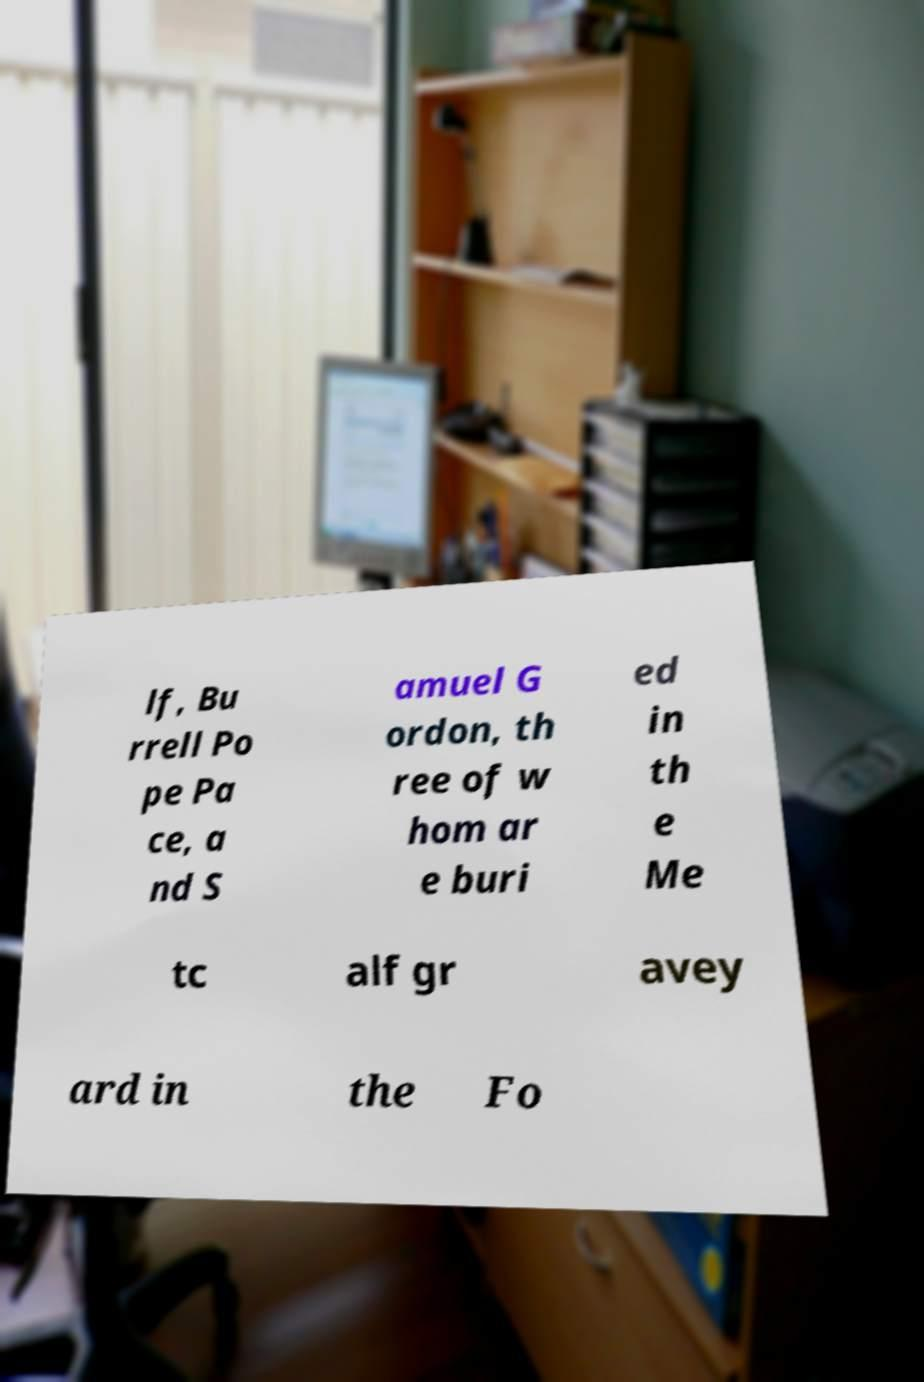Can you accurately transcribe the text from the provided image for me? lf, Bu rrell Po pe Pa ce, a nd S amuel G ordon, th ree of w hom ar e buri ed in th e Me tc alf gr avey ard in the Fo 